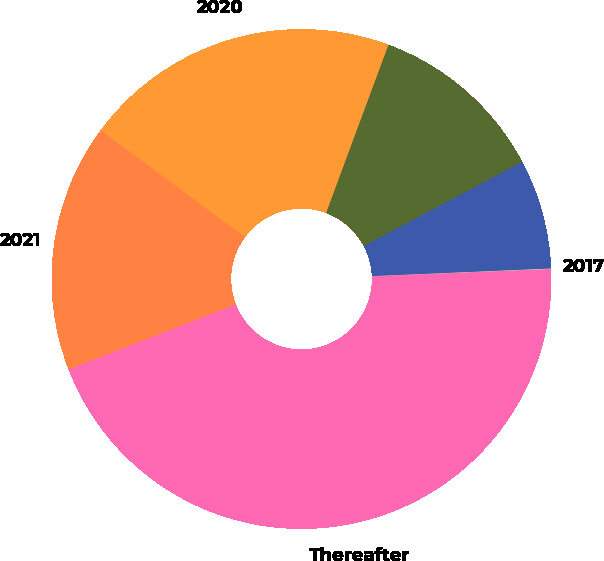<chart> <loc_0><loc_0><loc_500><loc_500><pie_chart><fcel>2017<fcel>2018<fcel>2019<fcel>2020<fcel>2021<fcel>Thereafter<nl><fcel>0.05%<fcel>7.1%<fcel>11.57%<fcel>20.51%<fcel>16.04%<fcel>44.73%<nl></chart> 